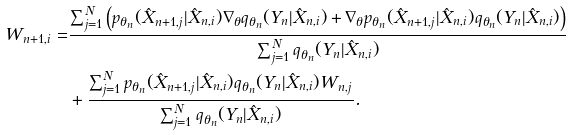<formula> <loc_0><loc_0><loc_500><loc_500>W _ { n + 1 , i } = & \frac { \sum _ { j = 1 } ^ { N } \left ( p _ { \theta _ { n } } ( \hat { X } _ { n + 1 , j } | \hat { X } _ { n , i } ) \nabla _ { \theta } q _ { \theta _ { n } } ( Y _ { n } | \hat { X } _ { n , i } ) + \nabla _ { \theta } p _ { \theta _ { n } } ( \hat { X } _ { n + 1 , j } | \hat { X } _ { n , i } ) q _ { \theta _ { n } } ( Y _ { n } | \hat { X } _ { n , i } ) \right ) } { \sum _ { j = 1 } ^ { N } q _ { \theta _ { n } } ( Y _ { n } | \hat { X } _ { n , i } ) } \\ & + \frac { \sum _ { j = 1 } ^ { N } p _ { \theta _ { n } } ( \hat { X } _ { n + 1 , j } | \hat { X } _ { n , i } ) q _ { \theta _ { n } } ( Y _ { n } | \hat { X } _ { n , i } ) W _ { n , j } } { \sum _ { j = 1 } ^ { N } q _ { \theta _ { n } } ( Y _ { n } | \hat { X } _ { n , i } ) } .</formula> 